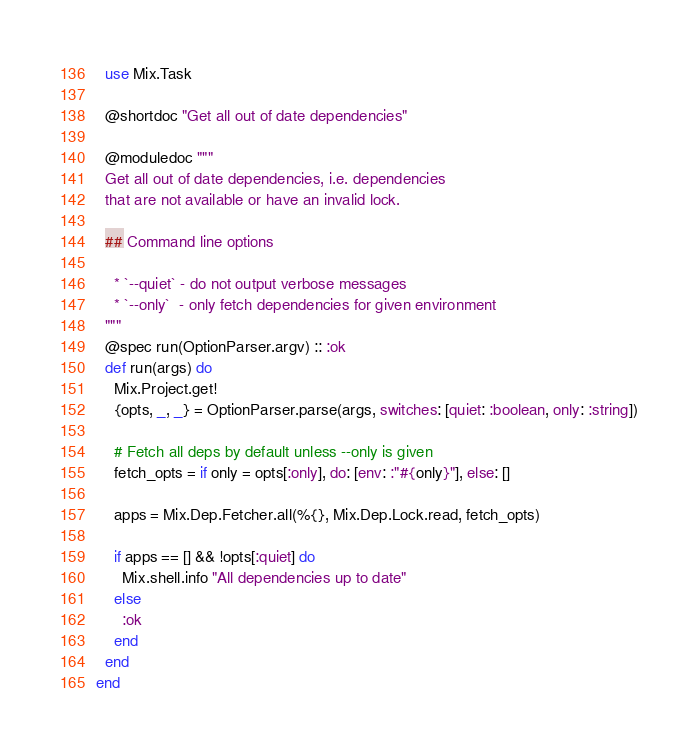<code> <loc_0><loc_0><loc_500><loc_500><_Elixir_>  use Mix.Task

  @shortdoc "Get all out of date dependencies"

  @moduledoc """
  Get all out of date dependencies, i.e. dependencies
  that are not available or have an invalid lock.

  ## Command line options

    * `--quiet` - do not output verbose messages
    * `--only`  - only fetch dependencies for given environment
  """
  @spec run(OptionParser.argv) :: :ok
  def run(args) do
    Mix.Project.get!
    {opts, _, _} = OptionParser.parse(args, switches: [quiet: :boolean, only: :string])

    # Fetch all deps by default unless --only is given
    fetch_opts = if only = opts[:only], do: [env: :"#{only}"], else: []

    apps = Mix.Dep.Fetcher.all(%{}, Mix.Dep.Lock.read, fetch_opts)

    if apps == [] && !opts[:quiet] do
      Mix.shell.info "All dependencies up to date"
    else
      :ok
    end
  end
end
</code> 